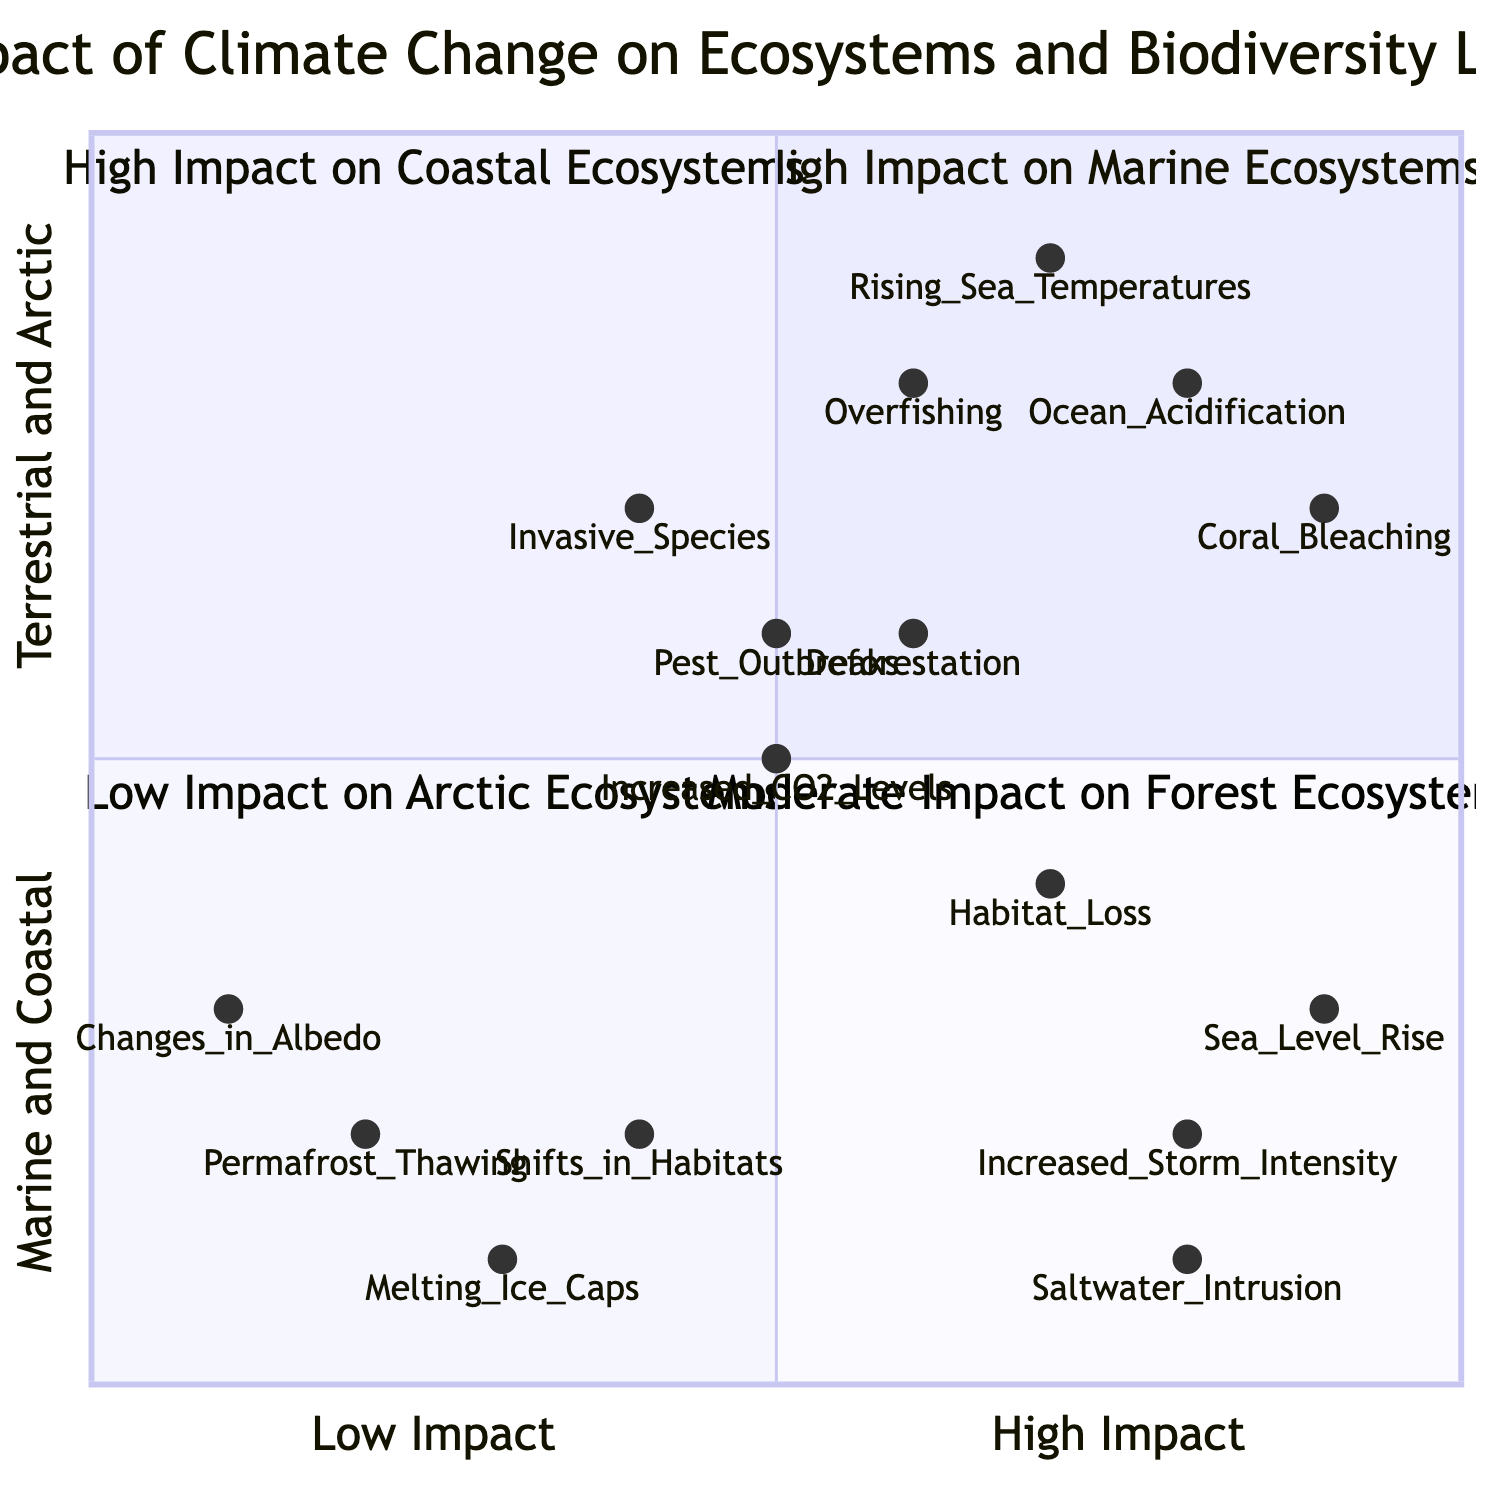What are the high-impact variables affecting marine ecosystems? The high-impact variables affecting marine ecosystems, as shown in the diagram, are Ocean Acidification, Rising Sea Temperatures, Coral Bleaching, and Overfishing. These variables are located in Quadrant 1, which is designated for high impact on marine ecosystems.
Answer: Ocean Acidification, Rising Sea Temperatures, Coral Bleaching, Overfishing What is the predicted biodiversity loss for coastal ecosystems in 2050? The predicted biodiversity loss for coastal ecosystems in 2050, according to the diagram, is a 25% decline. This information is explicitly stated in Quadrant 2, which focuses on high impact on coastal ecosystems.
Answer: 25% decline Which quadrant has the lowest predicted biodiversity loss in 2030? The quadrant with the lowest predicted biodiversity loss in 2030 is Quadrant 3, which deals with Arctic ecosystems. It specifically indicates a 2% decline in Arctic biodiversity, making it the lowest among the four quadrants.
Answer: Low Impact on Arctic Ecosystems How many high-impact variables are listed for forest ecosystems? For forest ecosystems, as shown in Quadrant 4, there are four high-impact variables, which are Increased CO2 Levels, Deforestation, Invasive Species, and Pest Outbreaks. This count demonstrates the range of variables influencing biodiversity in forest ecosystems.
Answer: 4 What is the predicted biodiversity decline for marine ecosystems in 2030? The predicted biodiversity decline for marine ecosystems in 2030 is a 10% decline. This specific prediction can be found in Quadrant 1, which highlights the impact of climate change variables on marine ecosystems.
Answer: 10% decline Which ecosystem is predicted to experience the least decline in biodiversity by 2050? The ecosystem predicted to experience the least decline in biodiversity by 2050 is the Arctic ecosystem, with a projected 7% decline. This prediction comes from Quadrant 3, which is designated for low-impact variations in the Arctic.
Answer: 7% decline 